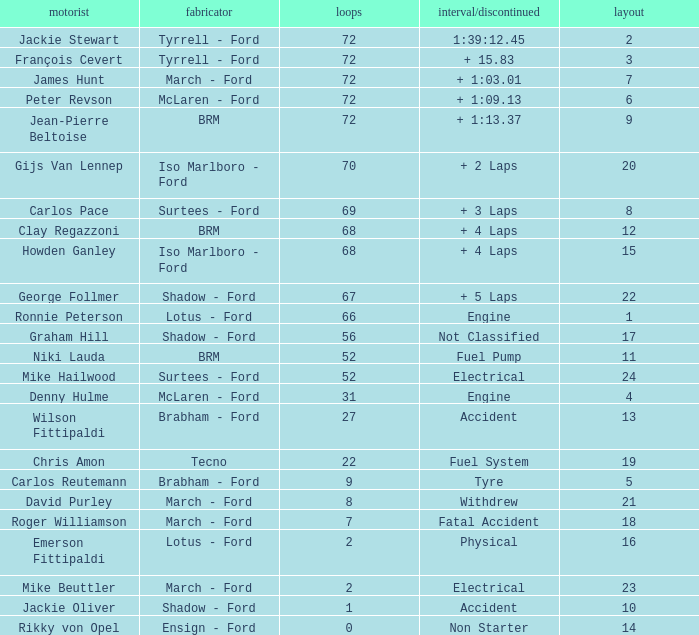What is the top grid that roger williamson lapped less than 7? None. 